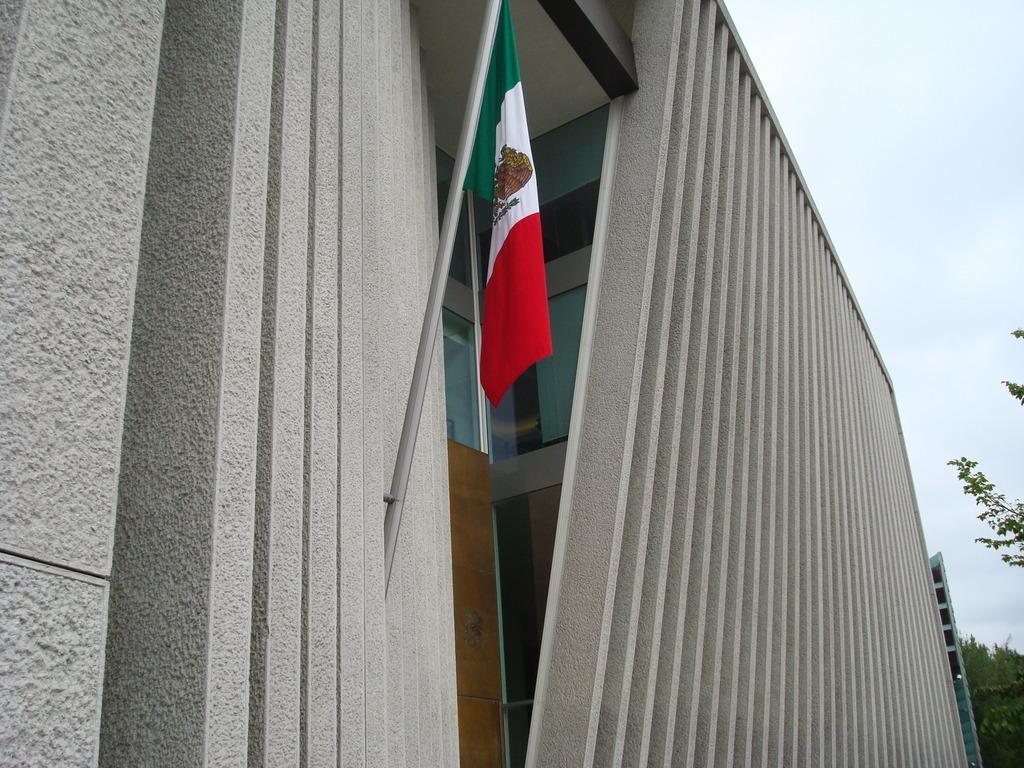In one or two sentences, can you explain what this image depicts? This picture is clicked outside. On the left there is a flag attached to the wall of a building. In the background we can see the sky, trees and a building. 